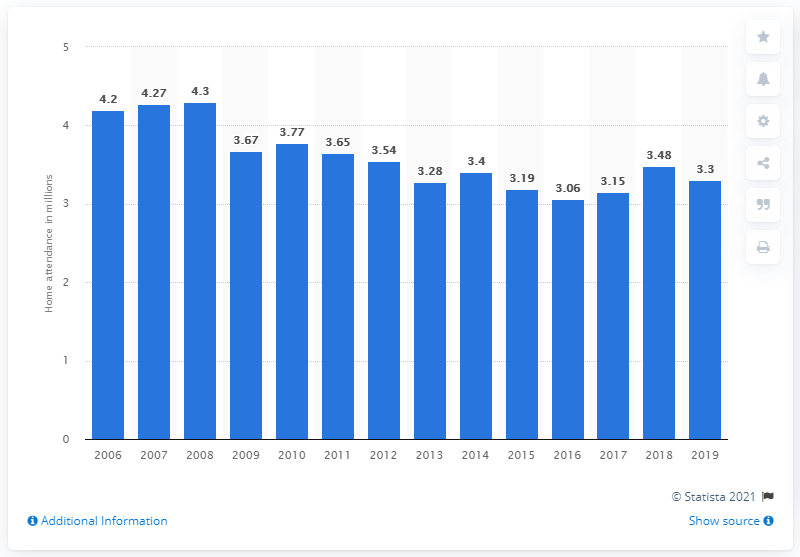Mention a couple of crucial points in this snapshot. In 2019, the New York Yankees had an average regular season home attendance of 3,300 fans. 